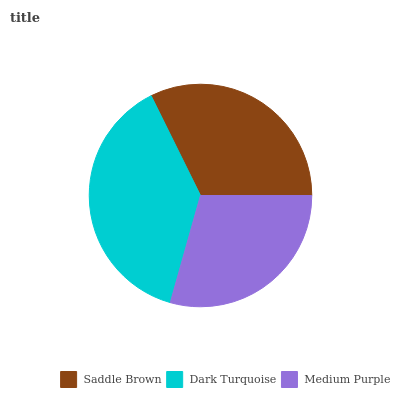Is Medium Purple the minimum?
Answer yes or no. Yes. Is Dark Turquoise the maximum?
Answer yes or no. Yes. Is Dark Turquoise the minimum?
Answer yes or no. No. Is Medium Purple the maximum?
Answer yes or no. No. Is Dark Turquoise greater than Medium Purple?
Answer yes or no. Yes. Is Medium Purple less than Dark Turquoise?
Answer yes or no. Yes. Is Medium Purple greater than Dark Turquoise?
Answer yes or no. No. Is Dark Turquoise less than Medium Purple?
Answer yes or no. No. Is Saddle Brown the high median?
Answer yes or no. Yes. Is Saddle Brown the low median?
Answer yes or no. Yes. Is Medium Purple the high median?
Answer yes or no. No. Is Dark Turquoise the low median?
Answer yes or no. No. 